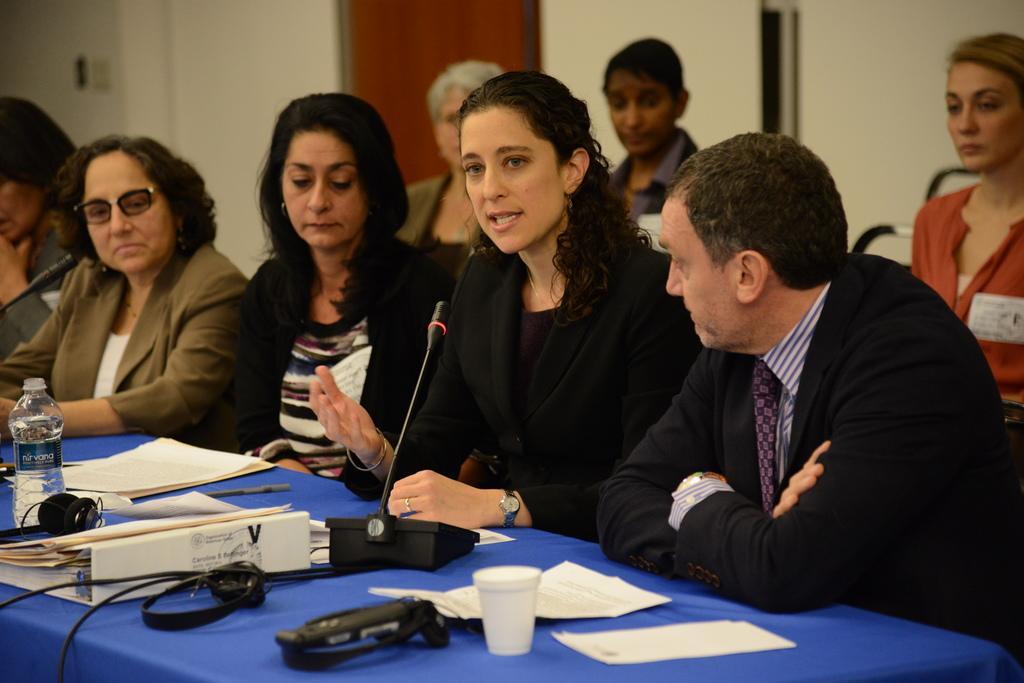Describe this image in one or two sentences. On the right side a beautiful girl is sitting and speaking in the microphone, she wore black color dress. On the left side three other persons are sitting beside of her. On the right side a man is there, he wore black color coat. 